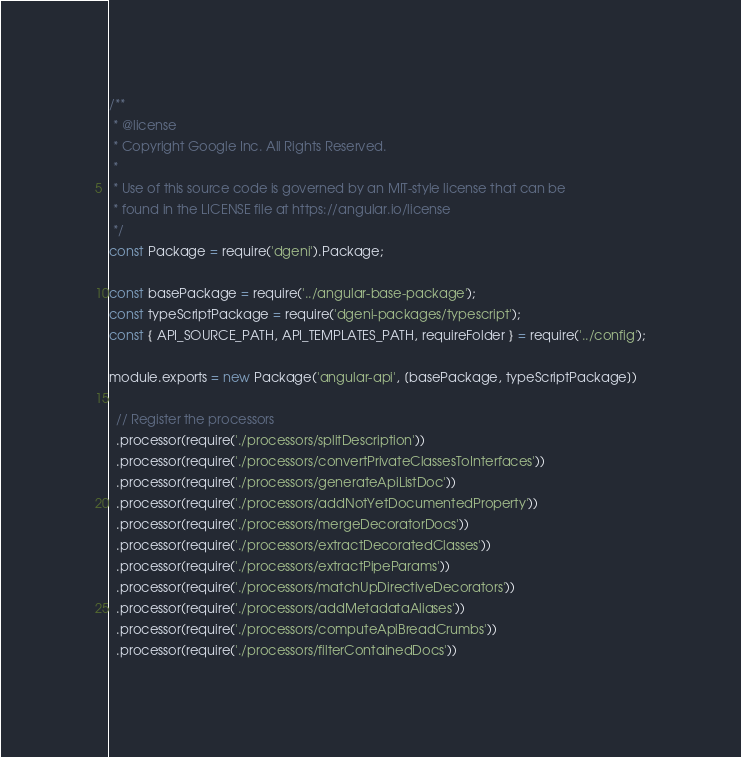Convert code to text. <code><loc_0><loc_0><loc_500><loc_500><_JavaScript_>/**
 * @license
 * Copyright Google Inc. All Rights Reserved.
 *
 * Use of this source code is governed by an MIT-style license that can be
 * found in the LICENSE file at https://angular.io/license
 */
const Package = require('dgeni').Package;

const basePackage = require('../angular-base-package');
const typeScriptPackage = require('dgeni-packages/typescript');
const { API_SOURCE_PATH, API_TEMPLATES_PATH, requireFolder } = require('../config');

module.exports = new Package('angular-api', [basePackage, typeScriptPackage])

  // Register the processors
  .processor(require('./processors/splitDescription'))
  .processor(require('./processors/convertPrivateClassesToInterfaces'))
  .processor(require('./processors/generateApiListDoc'))
  .processor(require('./processors/addNotYetDocumentedProperty'))
  .processor(require('./processors/mergeDecoratorDocs'))
  .processor(require('./processors/extractDecoratedClasses'))
  .processor(require('./processors/extractPipeParams'))
  .processor(require('./processors/matchUpDirectiveDecorators'))
  .processor(require('./processors/addMetadataAliases'))
  .processor(require('./processors/computeApiBreadCrumbs'))
  .processor(require('./processors/filterContainedDocs'))</code> 